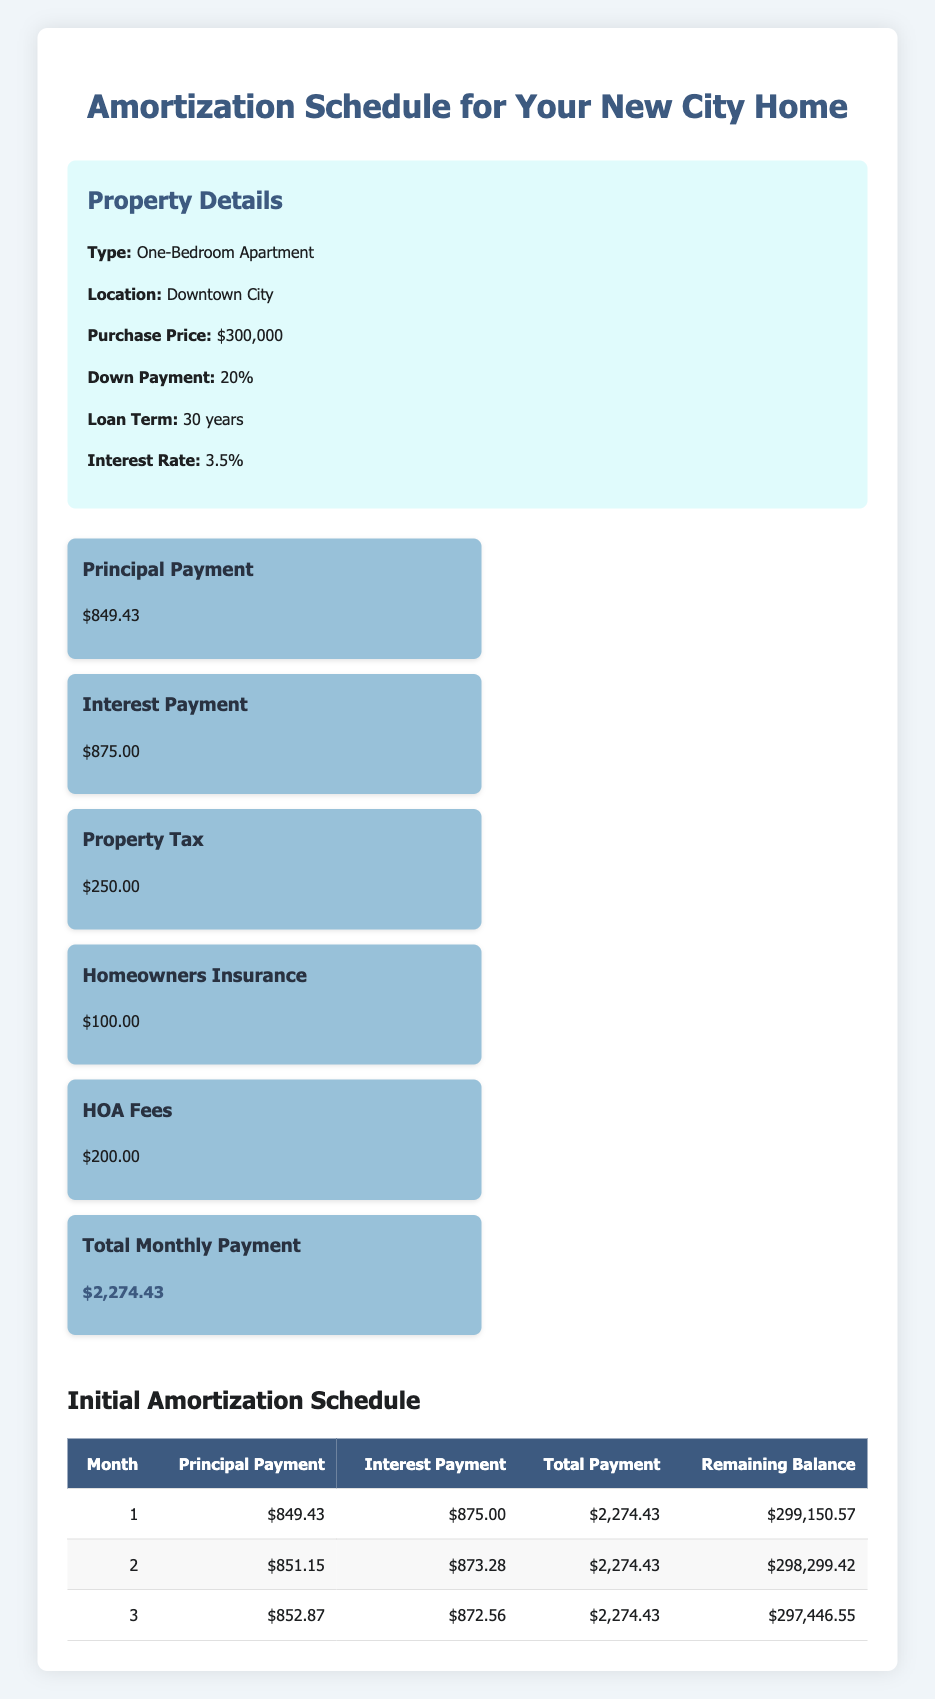What is the total monthly payment for the apartment? The total monthly payment is listed at the bottom of the monthly breakdown section, which shows a total of $2,274.43.
Answer: 2,274.43 How much is the principal payment for the first month? The principal payment for the first month can be found in the initial amortization schedule table, which states the principal payment is $849.43.
Answer: 849.43 What is the interest payment in the second month? The interest payment for the second month can be obtained from the initial amortization schedule, where it lists the interest payment as $873.28 for month 2.
Answer: 873.28 Is the homeowners insurance included in the total monthly payment? Yes, the homeowners insurance of $100.00 is included as part of the total monthly payment breakdown, which accounts for monthly expenses.
Answer: Yes What is the remaining balance after the third month? To find the remaining balance after the third month, look at the initial amortization table which displays a remaining balance of $297,446.55 at month 3.
Answer: 297,446.55 What is the difference between the total payment and the principal payment for the first month? To calculate the difference, subtract the principal payment for the first month ($849.43) from the total payment ($2,274.43). So, $2,274.43 - $849.43 = $1,425.00.
Answer: 1,425.00 If I sum up the principal payments of the first three months, what is the total? The sum of the principal payments is calculated by adding all the principal payments together: $849.43 (month 1) + $851.15 (month 2) + $852.87 (month 3) = $2,553.45.
Answer: 2,553.45 What is the average interest payment over the first three months? To find the average interest payment, add up all the interest payments from the first three months ($875.00 + $873.28 + $872.56 = $2,620.84), and then divide by the number of months (3): $2,620.84 / 3 = $873.61.
Answer: 873.61 Is the HOA fee part of the property tax? No, the HOA fee of $200.00 is listed separately in the monthly breakdown, indicating it is not part of the property tax which is listed as $250.00.
Answer: No 